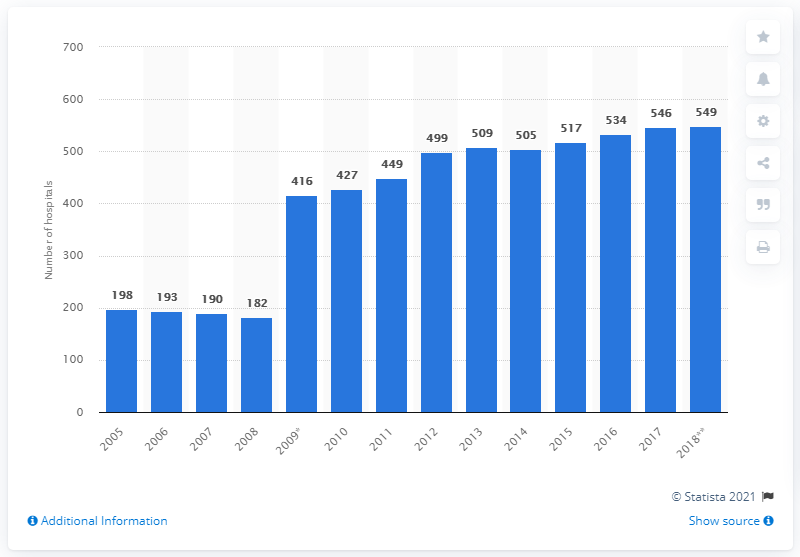Point out several critical features in this image. In 2018, there were 549 hospitals in the Netherlands. 